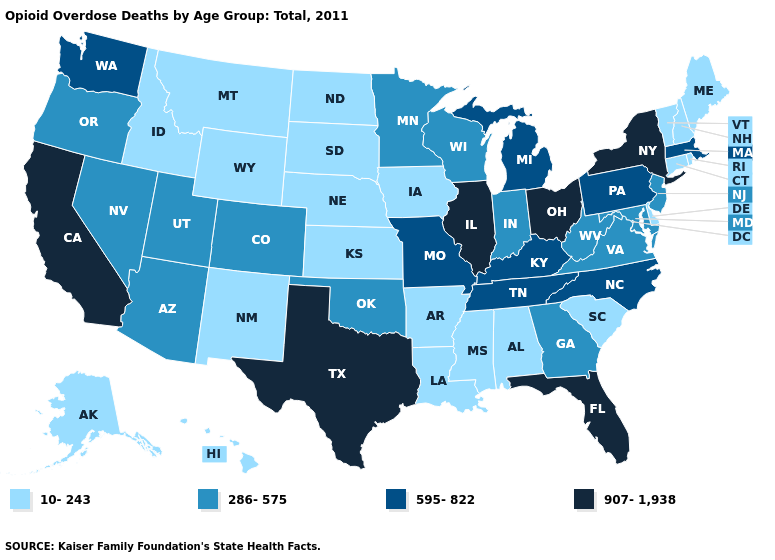Among the states that border Utah , does Colorado have the lowest value?
Quick response, please. No. Does Missouri have the lowest value in the MidWest?
Quick response, please. No. Does Florida have the highest value in the USA?
Give a very brief answer. Yes. What is the highest value in states that border Wyoming?
Concise answer only. 286-575. Is the legend a continuous bar?
Short answer required. No. What is the highest value in states that border California?
Quick response, please. 286-575. Does Texas have the highest value in the South?
Write a very short answer. Yes. Which states hav the highest value in the MidWest?
Write a very short answer. Illinois, Ohio. Does Utah have a higher value than North Carolina?
Give a very brief answer. No. How many symbols are there in the legend?
Give a very brief answer. 4. Does South Dakota have the lowest value in the MidWest?
Concise answer only. Yes. Is the legend a continuous bar?
Give a very brief answer. No. Does Washington have a higher value than Ohio?
Write a very short answer. No. What is the value of Delaware?
Write a very short answer. 10-243. 